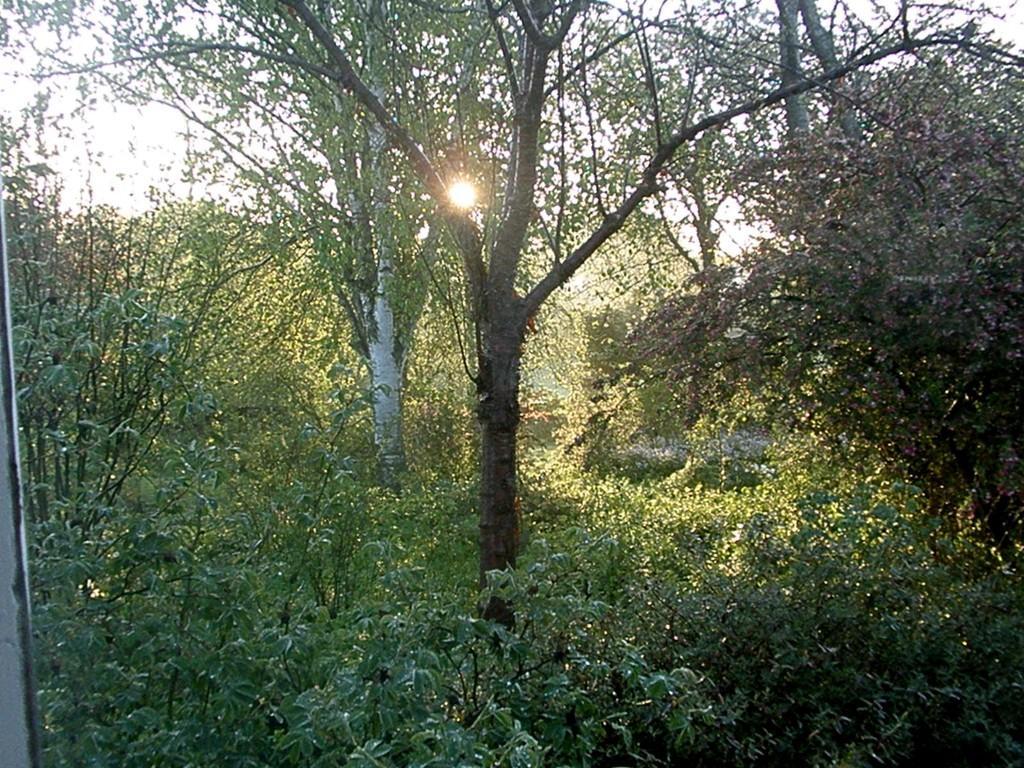How would you summarize this image in a sentence or two? In this image there are trees and plants. And there is a sun in between the tree. And at the top there is a sky. 